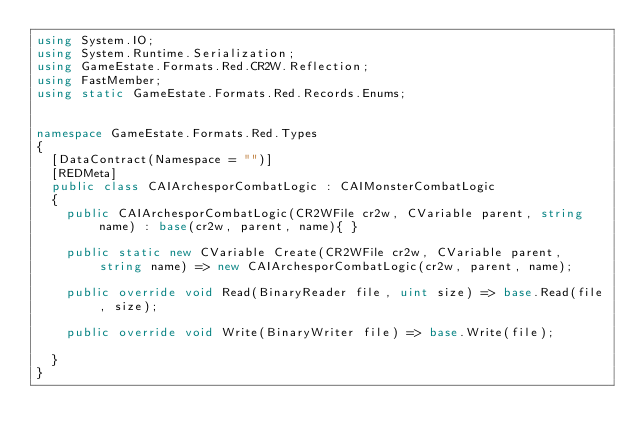Convert code to text. <code><loc_0><loc_0><loc_500><loc_500><_C#_>using System.IO;
using System.Runtime.Serialization;
using GameEstate.Formats.Red.CR2W.Reflection;
using FastMember;
using static GameEstate.Formats.Red.Records.Enums;


namespace GameEstate.Formats.Red.Types
{
	[DataContract(Namespace = "")]
	[REDMeta]
	public class CAIArchesporCombatLogic : CAIMonsterCombatLogic
	{
		public CAIArchesporCombatLogic(CR2WFile cr2w, CVariable parent, string name) : base(cr2w, parent, name){ }

		public static new CVariable Create(CR2WFile cr2w, CVariable parent, string name) => new CAIArchesporCombatLogic(cr2w, parent, name);

		public override void Read(BinaryReader file, uint size) => base.Read(file, size);

		public override void Write(BinaryWriter file) => base.Write(file);

	}
}</code> 